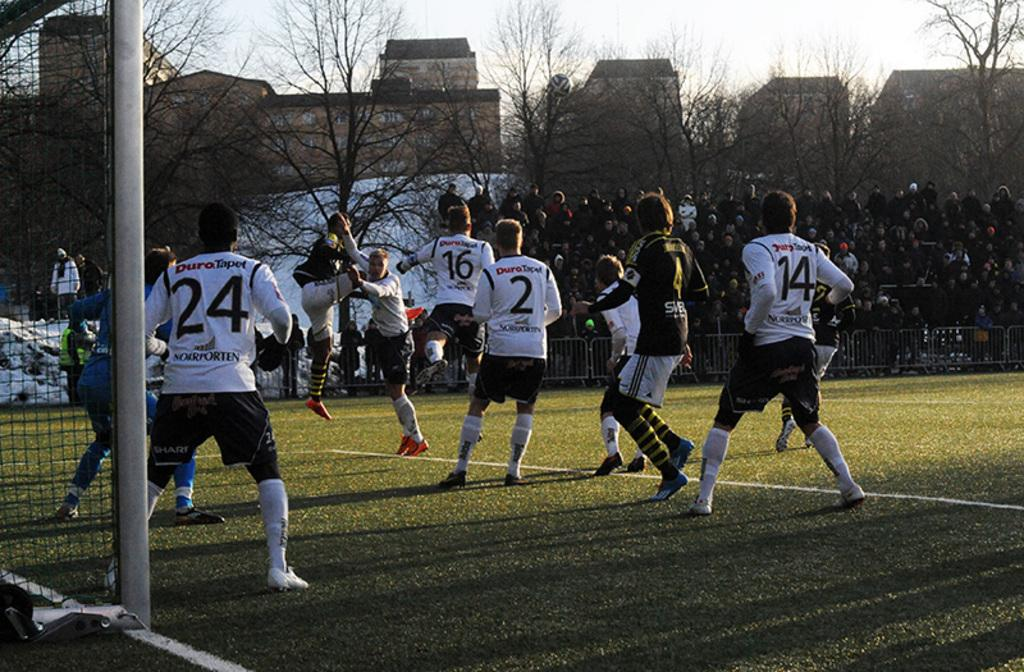What sport are the players engaged in within the image? The players are playing football in the image. Who is observing the game in the image? There is an audience watching the game in the image. What type of natural environment can be seen in the image? Trees are visible in the image. What type of man-made structures are present in the image? There are buildings in the image. What is the weather condition in the image? The sky is cloudy in the image. What type of tomatoes are being sold by the players during the game? There is no indication of tomatoes or any sales activity in the image; the players are focused on playing football. 